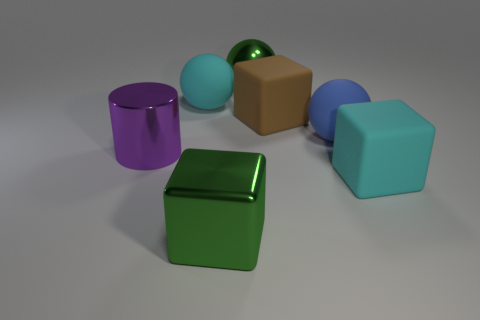What is the shape of the big cyan object that is to the right of the green object on the left side of the metallic sphere that is behind the purple metal cylinder? The large cyan object situated to the right of the green object, on the left side of the metallic sphere which is behind the purple metal cylinder, is a cube. The cube's flat faces are distinctly visible and it features the characteristic edges and corners that define a cubic shape. 